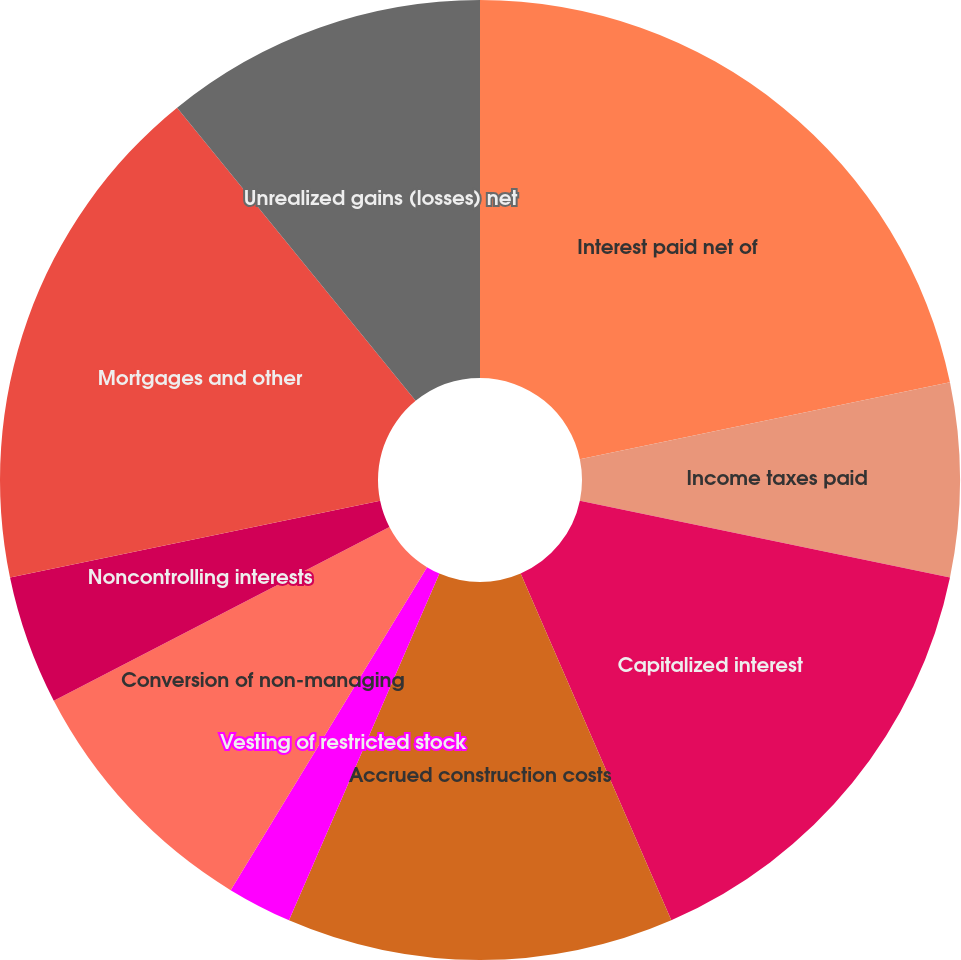Convert chart. <chart><loc_0><loc_0><loc_500><loc_500><pie_chart><fcel>Interest paid net of<fcel>Income taxes paid<fcel>Capitalized interest<fcel>Accrued construction costs<fcel>Vesting of restricted stock<fcel>Cancellation of restricted<fcel>Conversion of non-managing<fcel>Noncontrolling interests<fcel>Mortgages and other<fcel>Unrealized gains (losses) net<nl><fcel>21.74%<fcel>6.52%<fcel>15.22%<fcel>13.04%<fcel>2.18%<fcel>0.0%<fcel>8.7%<fcel>4.35%<fcel>17.39%<fcel>10.87%<nl></chart> 